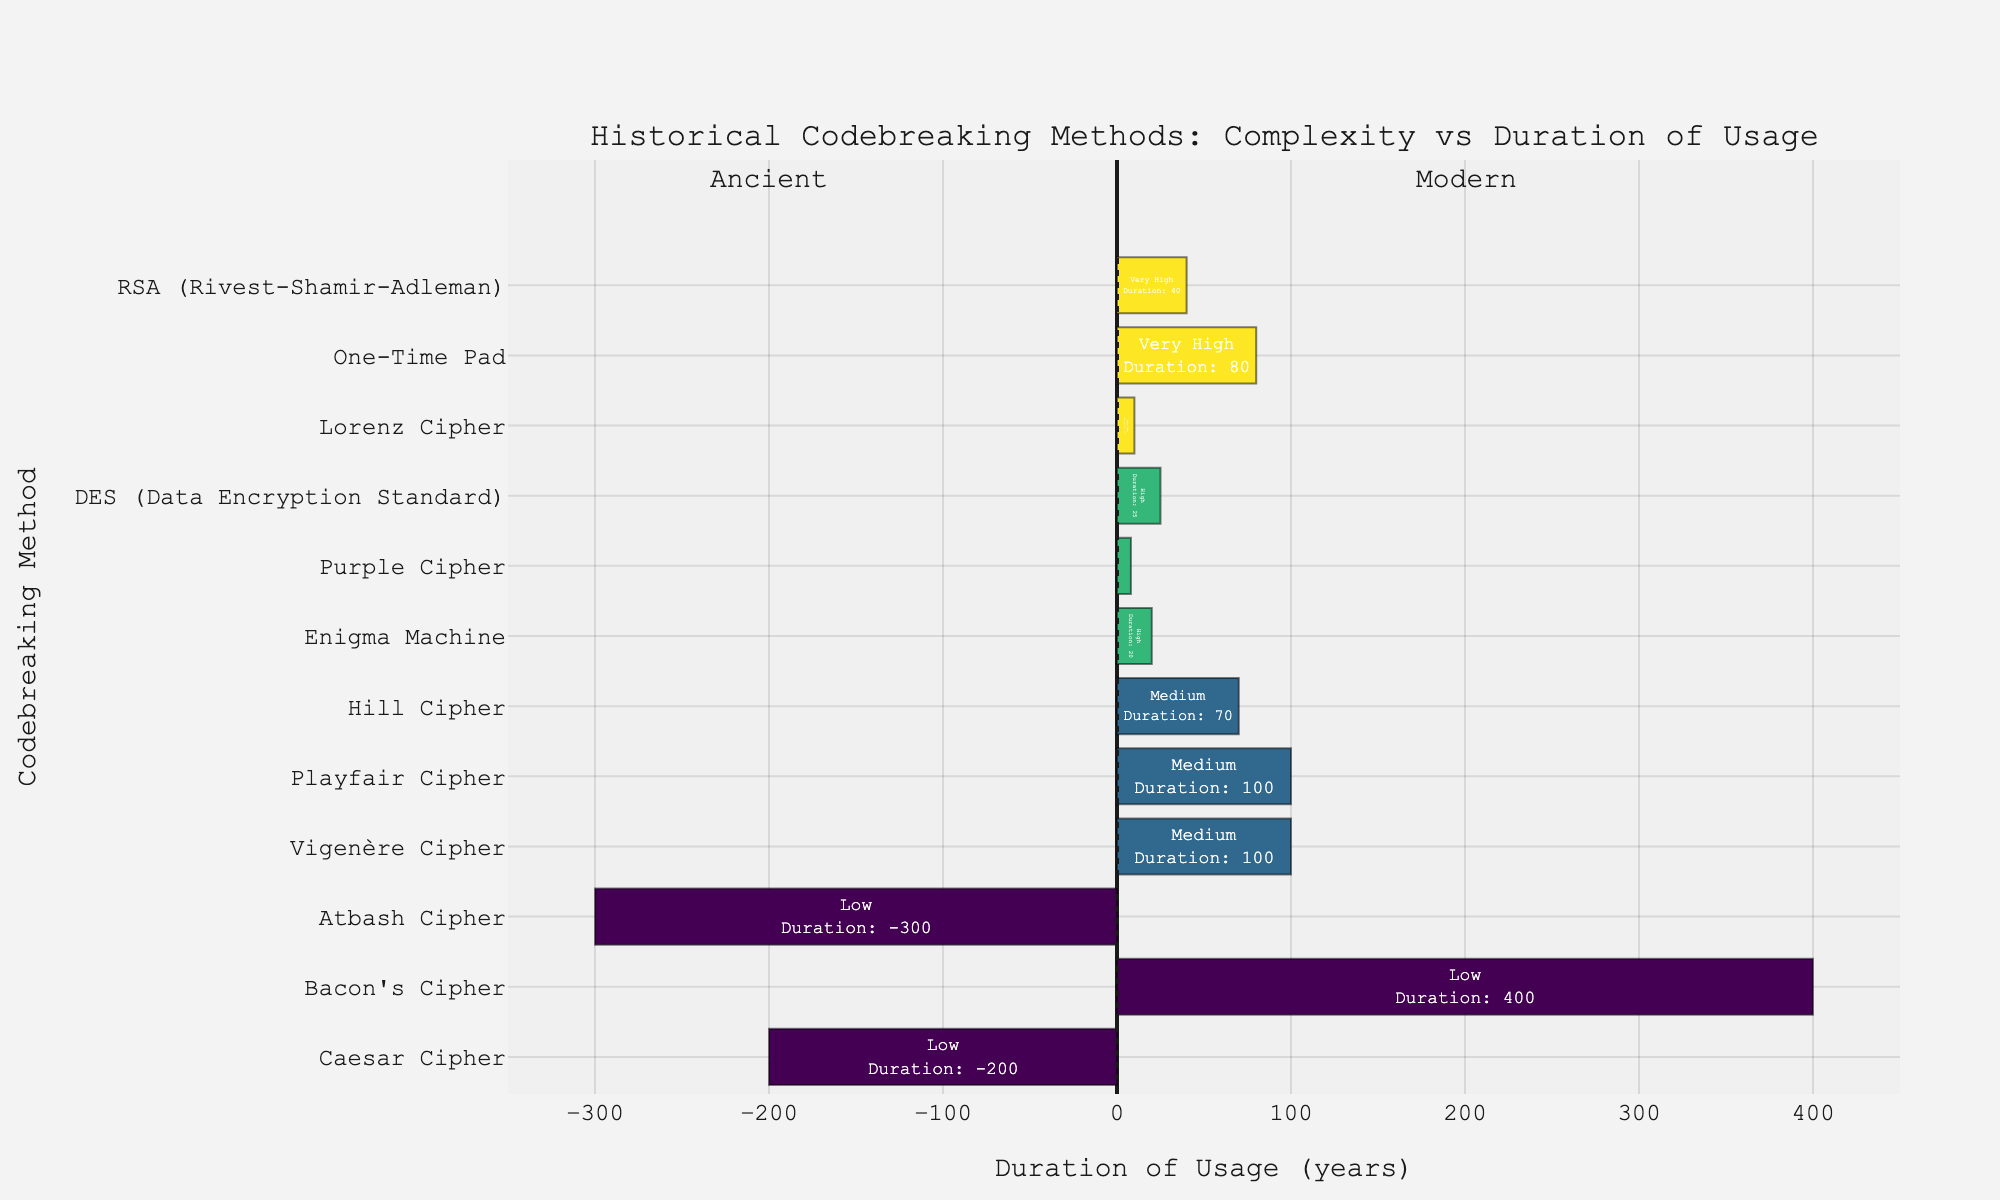What's the most complex codebreaking method shown? The methods are color-coded by complexity, with a higher numerical value indicating higher complexity. "Very High" complexity is represented by the highest color intensity. Among the methods listed, "Lorenz Cipher," "One-Time Pad," and "RSA" are the most complex.
Answer: Lorenz Cipher, One-Time Pad, RSA Which method has been used the longest? The length of the bars indicates the duration of usage. The method with the longest duration bar is "Bacon's Cipher," which stretches to 400 years.
Answer: Bacon's Cipher How does the usage duration of the Caesar Cipher compare to the Atbash Cipher? Both "Caesar Cipher" and "Atbash Cipher" have negative durations, indicating ancient usage. The bar for "Atbash Cipher" extends to -300 years, whereas the bar for "Caesar Cipher" extends to -200 years.
Answer: Atbash Cipher Which methods have a usage duration less than 50 years but are classified as "High" or "Very High" complexity? Find methods with bars within the 50-year duration limit and then check their complexity. The methods "Purple Cipher" and "DES" fall under this duration and are classified as "High" complexity.
Answer: Purple Cipher, DES What are the modern codebreaking methods classified with "Very High" complexity, and what is their combined usage duration? Modern methods have positive duration values. The methods with "Very High" complexity are "Lorenz Cipher," "One-Time Pad," and "RSA," with durations of 10, 80, and 40 years, respectively. Their combined duration is 10 + 80 + 40 = 130 years.
Answer: 130 years What is the average usage duration of methods classified as "Medium" complexity? The "Medium" complexity methods are "Vigenère Cipher," "Playfair Cipher," and "Hill Cipher," with durations of 100, 100, and 70 years, respectively. Their average duration is (100 + 100 + 70) / 3 = 90 years.
Answer: 90 years 